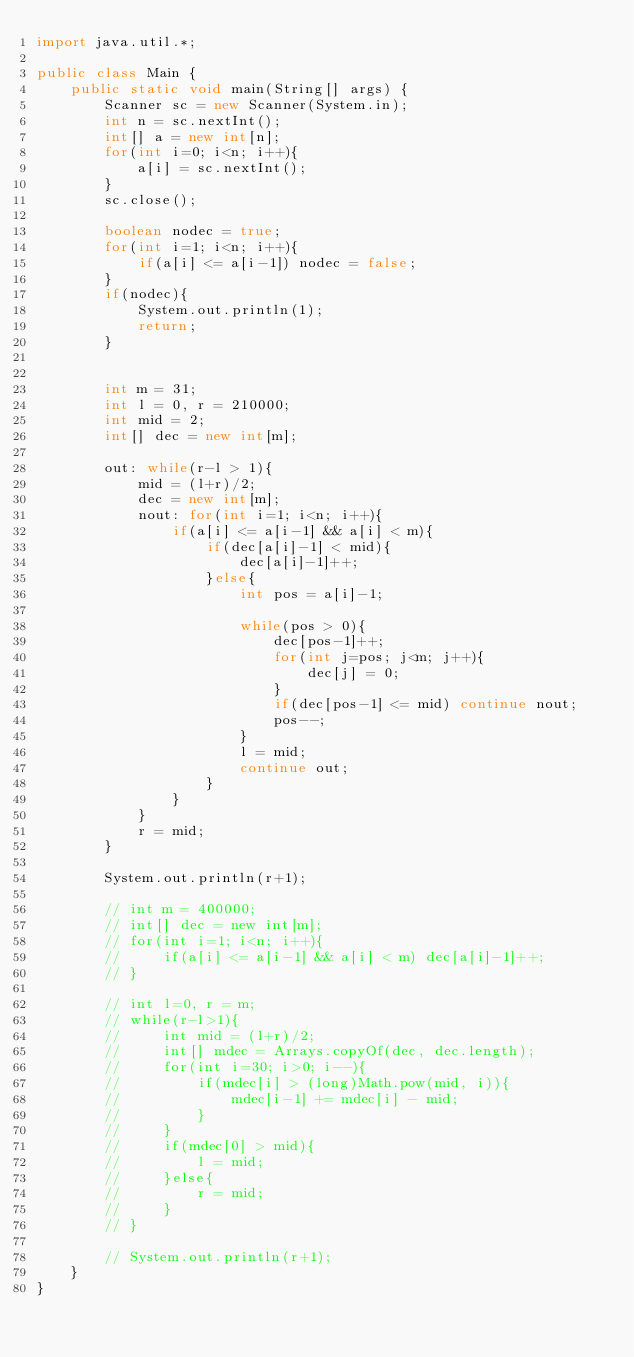<code> <loc_0><loc_0><loc_500><loc_500><_Java_>import java.util.*;

public class Main {
    public static void main(String[] args) {
        Scanner sc = new Scanner(System.in);
        int n = sc.nextInt();
        int[] a = new int[n];
        for(int i=0; i<n; i++){
            a[i] = sc.nextInt();
        }
        sc.close();

        boolean nodec = true;
        for(int i=1; i<n; i++){
            if(a[i] <= a[i-1]) nodec = false;
        }
        if(nodec){
            System.out.println(1);
            return;
        }

        
        int m = 31;
        int l = 0, r = 210000;
        int mid = 2;
        int[] dec = new int[m];

        out: while(r-l > 1){
            mid = (l+r)/2;
            dec = new int[m];
            nout: for(int i=1; i<n; i++){
                if(a[i] <= a[i-1] && a[i] < m){
                    if(dec[a[i]-1] < mid){
                        dec[a[i]-1]++;
                    }else{
                        int pos = a[i]-1;
                        
                        while(pos > 0){
                            dec[pos-1]++;
                            for(int j=pos; j<m; j++){
                                dec[j] = 0;
                            }
                            if(dec[pos-1] <= mid) continue nout;
                            pos--;
                        }
                        l = mid;
                        continue out;
                    }
                }
            }
            r = mid;
        }

        System.out.println(r+1);

        // int m = 400000;
        // int[] dec = new int[m];
        // for(int i=1; i<n; i++){
        //     if(a[i] <= a[i-1] && a[i] < m) dec[a[i]-1]++;
        // }

        // int l=0, r = m;
        // while(r-l>1){
        //     int mid = (l+r)/2;
        //     int[] mdec = Arrays.copyOf(dec, dec.length);
        //     for(int i=30; i>0; i--){
        //         if(mdec[i] > (long)Math.pow(mid, i)){
        //             mdec[i-1] += mdec[i] - mid;
        //         }
        //     }
        //     if(mdec[0] > mid){
        //         l = mid;
        //     }else{
        //         r = mid;
        //     }
        // }

        // System.out.println(r+1);
    }
}</code> 